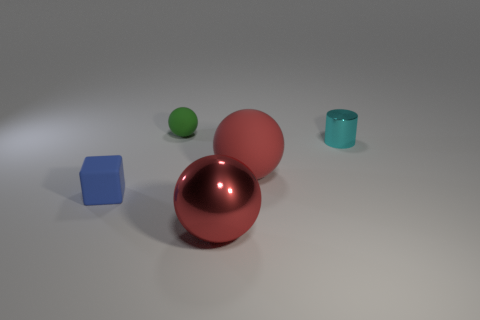Can you guess the texture of the objects? Certainly! The surfaces of the two larger spheres appear to be reflective and smooth, suggesting they could be made of a polished material like metal or plastic. The teal cylinder has a matte finish, possibly indicating a ceramic or plastic material. The green sphere and blue cube seem to have a solid, matte surface, possibly painted wood or plastic. 